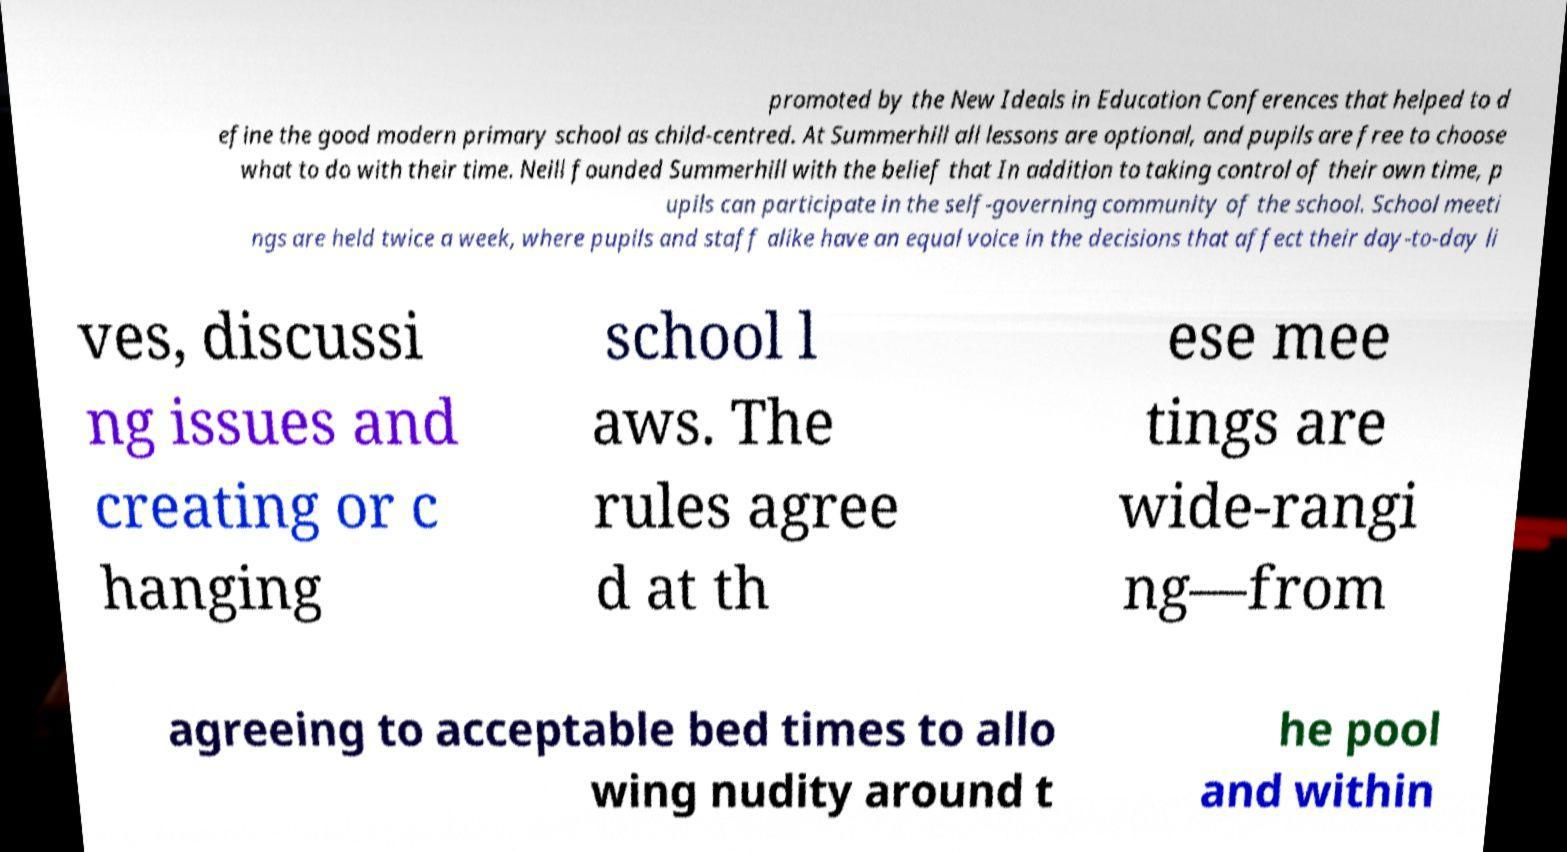I need the written content from this picture converted into text. Can you do that? promoted by the New Ideals in Education Conferences that helped to d efine the good modern primary school as child-centred. At Summerhill all lessons are optional, and pupils are free to choose what to do with their time. Neill founded Summerhill with the belief that In addition to taking control of their own time, p upils can participate in the self-governing community of the school. School meeti ngs are held twice a week, where pupils and staff alike have an equal voice in the decisions that affect their day-to-day li ves, discussi ng issues and creating or c hanging school l aws. The rules agree d at th ese mee tings are wide-rangi ng—from agreeing to acceptable bed times to allo wing nudity around t he pool and within 